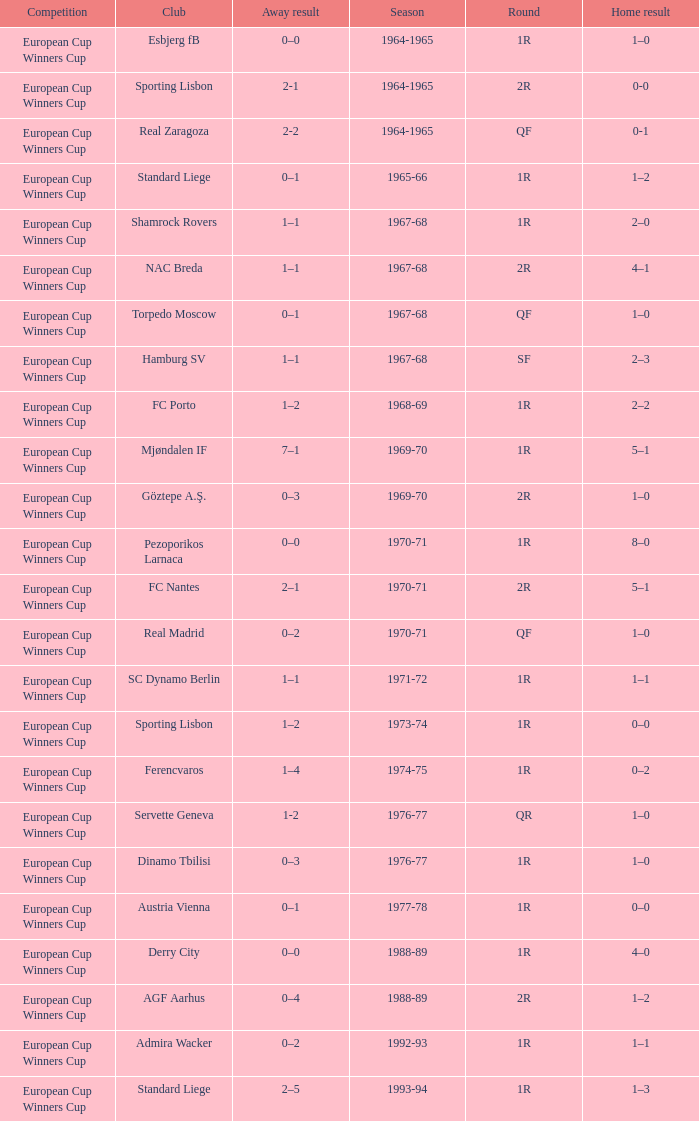Round of 1r, and an away result of 7–1 is what season? 1969-70. 